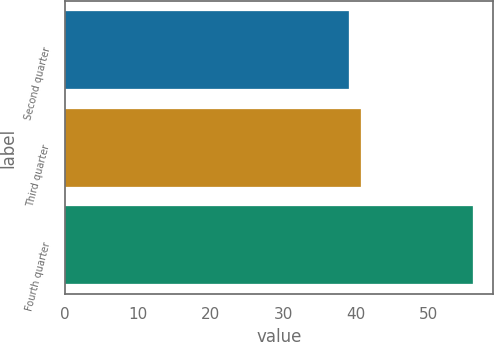Convert chart. <chart><loc_0><loc_0><loc_500><loc_500><bar_chart><fcel>Second quarter<fcel>Third quarter<fcel>Fourth quarter<nl><fcel>39<fcel>40.7<fcel>56<nl></chart> 